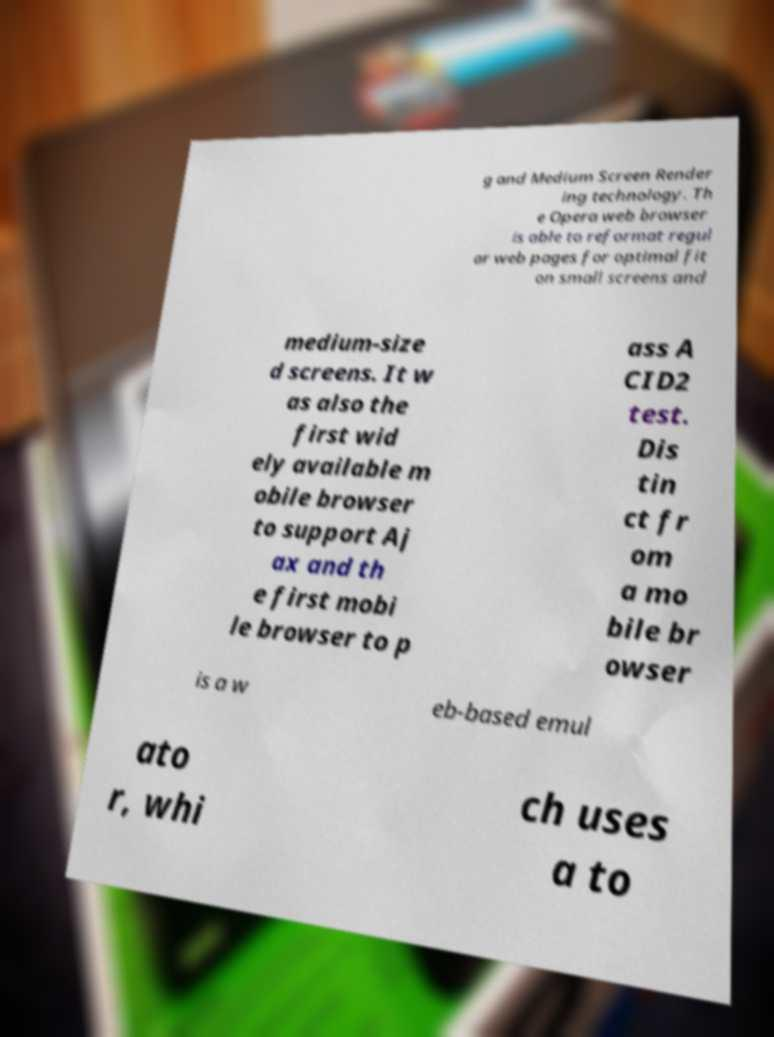Please read and relay the text visible in this image. What does it say? g and Medium Screen Render ing technology. Th e Opera web browser is able to reformat regul ar web pages for optimal fit on small screens and medium-size d screens. It w as also the first wid ely available m obile browser to support Aj ax and th e first mobi le browser to p ass A CID2 test. Dis tin ct fr om a mo bile br owser is a w eb-based emul ato r, whi ch uses a to 